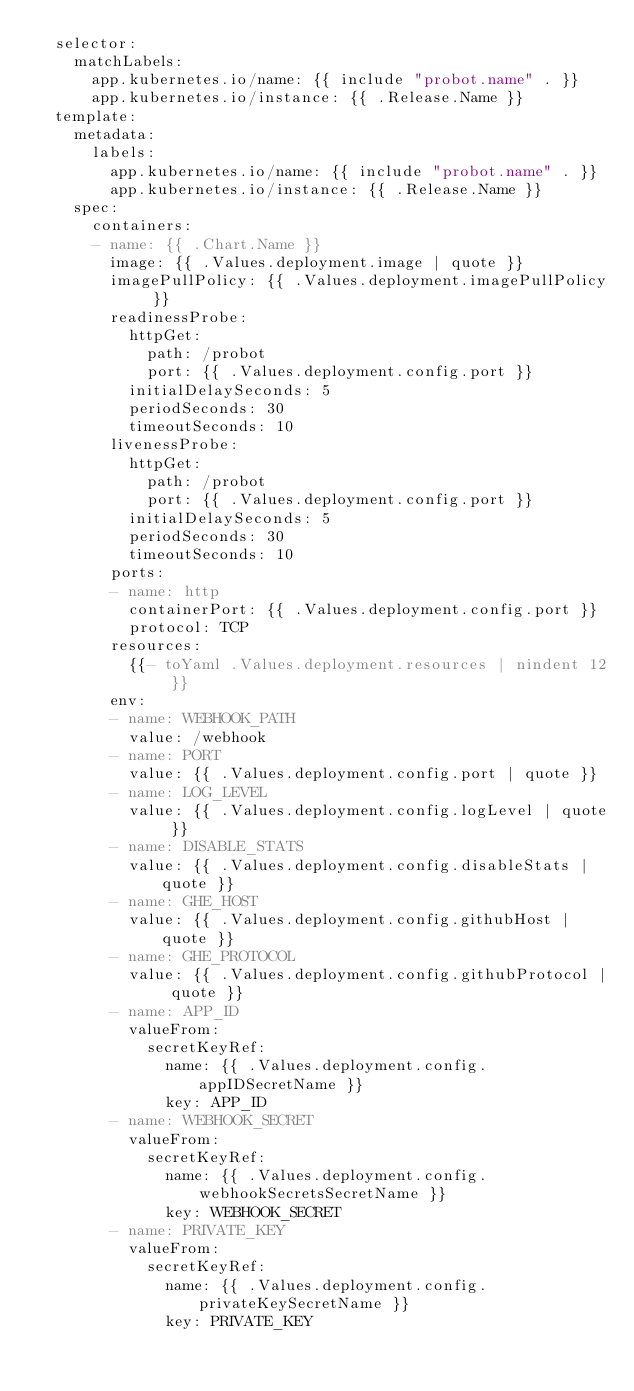<code> <loc_0><loc_0><loc_500><loc_500><_YAML_>  selector:
    matchLabels:
      app.kubernetes.io/name: {{ include "probot.name" . }}
      app.kubernetes.io/instance: {{ .Release.Name }}
  template:
    metadata:
      labels:
        app.kubernetes.io/name: {{ include "probot.name" . }}
        app.kubernetes.io/instance: {{ .Release.Name }}
    spec:
      containers:
      - name: {{ .Chart.Name }}
        image: {{ .Values.deployment.image | quote }}
        imagePullPolicy: {{ .Values.deployment.imagePullPolicy }}
        readinessProbe:
          httpGet:
            path: /probot
            port: {{ .Values.deployment.config.port }}
          initialDelaySeconds: 5
          periodSeconds: 30
          timeoutSeconds: 10
        livenessProbe:
          httpGet:
            path: /probot
            port: {{ .Values.deployment.config.port }}
          initialDelaySeconds: 5
          periodSeconds: 30
          timeoutSeconds: 10
        ports:
        - name: http
          containerPort: {{ .Values.deployment.config.port }}
          protocol: TCP
        resources:
          {{- toYaml .Values.deployment.resources | nindent 12 }}
        env:
        - name: WEBHOOK_PATH
          value: /webhook
        - name: PORT
          value: {{ .Values.deployment.config.port | quote }}
        - name: LOG_LEVEL
          value: {{ .Values.deployment.config.logLevel | quote }}
        - name: DISABLE_STATS
          value: {{ .Values.deployment.config.disableStats | quote }}
        - name: GHE_HOST
          value: {{ .Values.deployment.config.githubHost | quote }}
        - name: GHE_PROTOCOL
          value: {{ .Values.deployment.config.githubProtocol | quote }}
        - name: APP_ID
          valueFrom:
            secretKeyRef:
              name: {{ .Values.deployment.config.appIDSecretName }}
              key: APP_ID
        - name: WEBHOOK_SECRET
          valueFrom:
            secretKeyRef:
              name: {{ .Values.deployment.config.webhookSecretsSecretName }}
              key: WEBHOOK_SECRET
        - name: PRIVATE_KEY
          valueFrom:
            secretKeyRef:
              name: {{ .Values.deployment.config.privateKeySecretName }}
              key: PRIVATE_KEY
</code> 